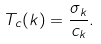Convert formula to latex. <formula><loc_0><loc_0><loc_500><loc_500>T _ { c } ( k ) = \frac { \sigma _ { k } } { c _ { k } } .</formula> 